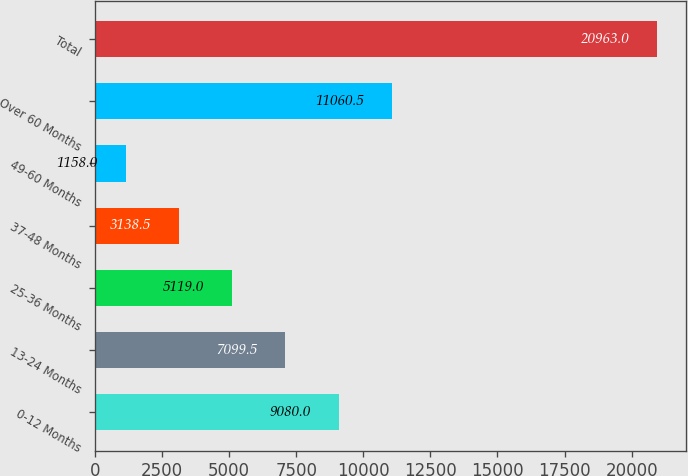<chart> <loc_0><loc_0><loc_500><loc_500><bar_chart><fcel>0-12 Months<fcel>13-24 Months<fcel>25-36 Months<fcel>37-48 Months<fcel>49-60 Months<fcel>Over 60 Months<fcel>Total<nl><fcel>9080<fcel>7099.5<fcel>5119<fcel>3138.5<fcel>1158<fcel>11060.5<fcel>20963<nl></chart> 